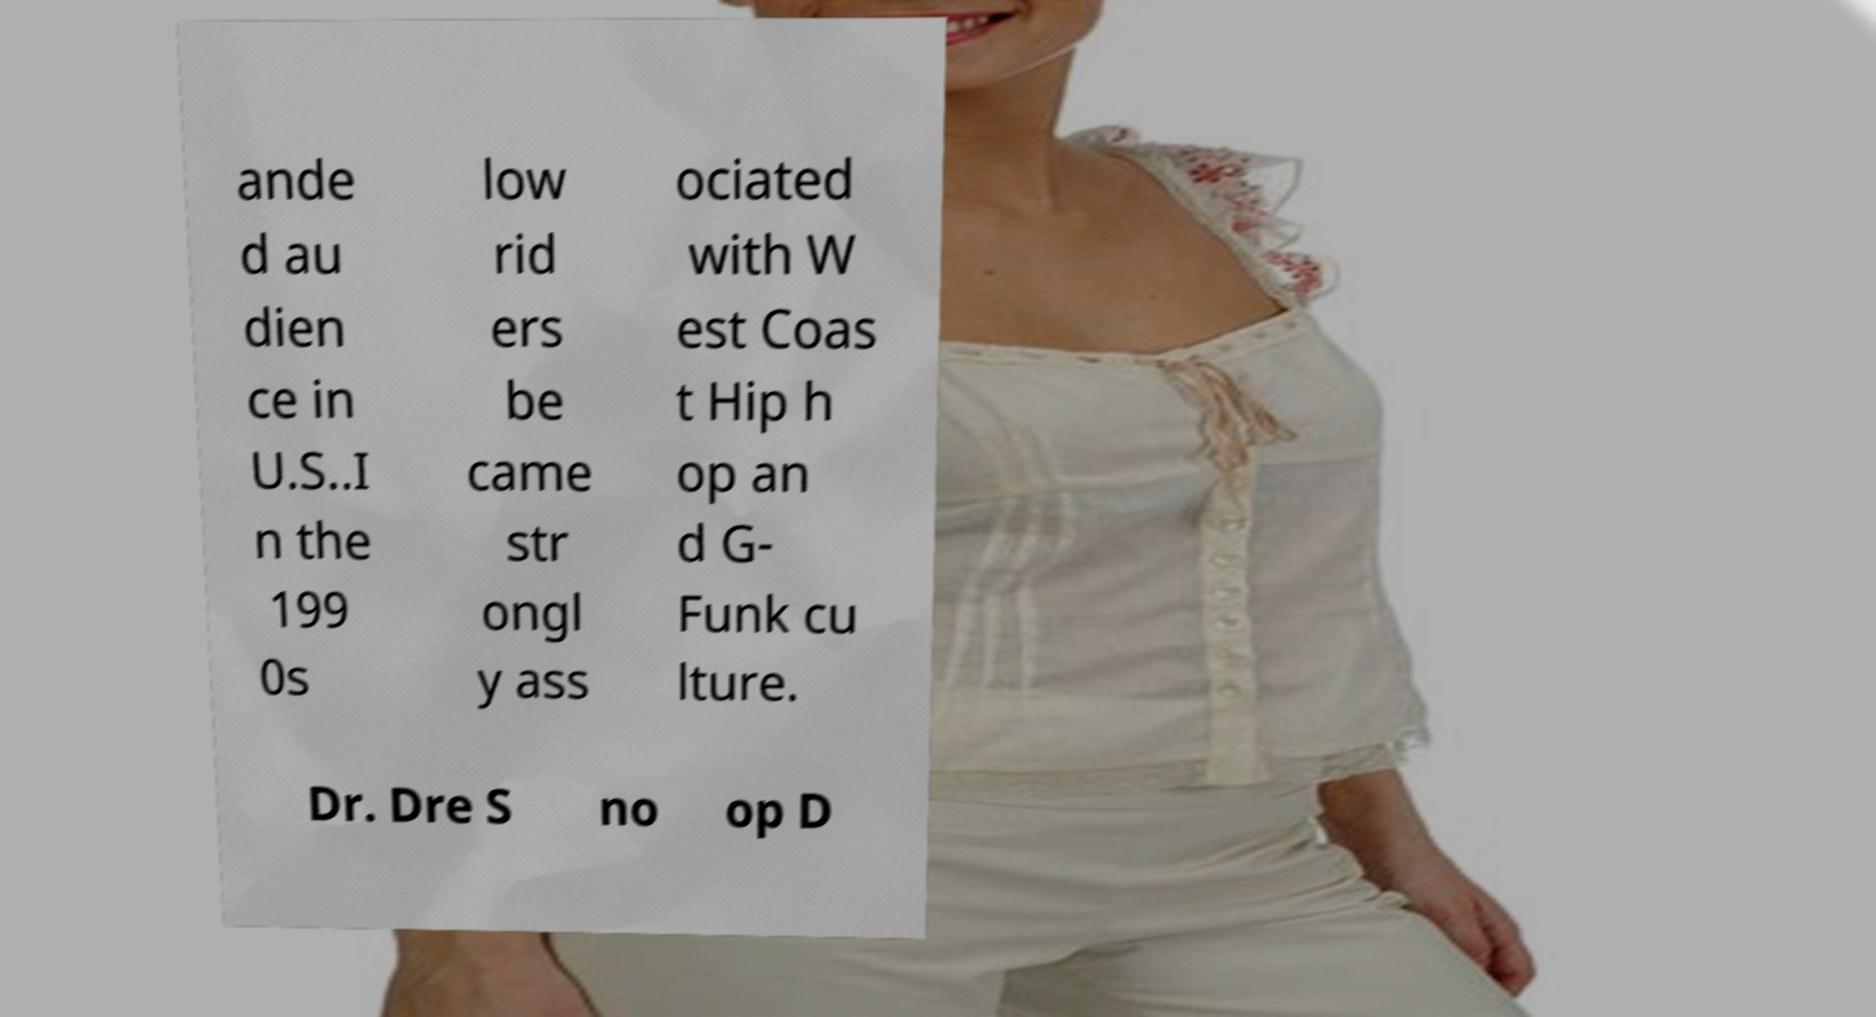Could you assist in decoding the text presented in this image and type it out clearly? ande d au dien ce in U.S..I n the 199 0s low rid ers be came str ongl y ass ociated with W est Coas t Hip h op an d G- Funk cu lture. Dr. Dre S no op D 